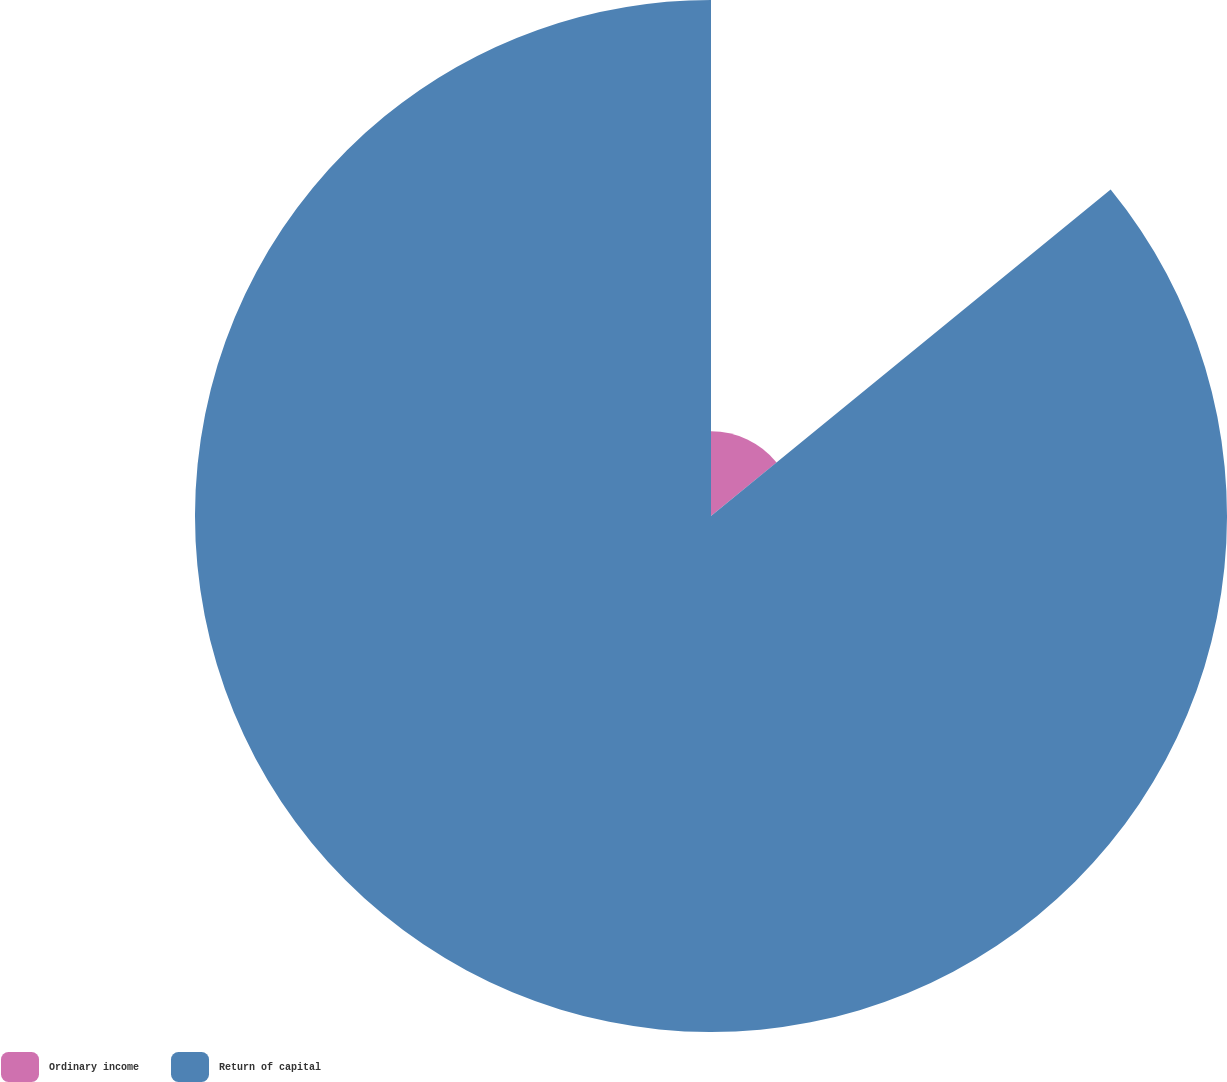Convert chart to OTSL. <chart><loc_0><loc_0><loc_500><loc_500><pie_chart><fcel>Ordinary income<fcel>Return of capital<nl><fcel>14.1%<fcel>85.9%<nl></chart> 